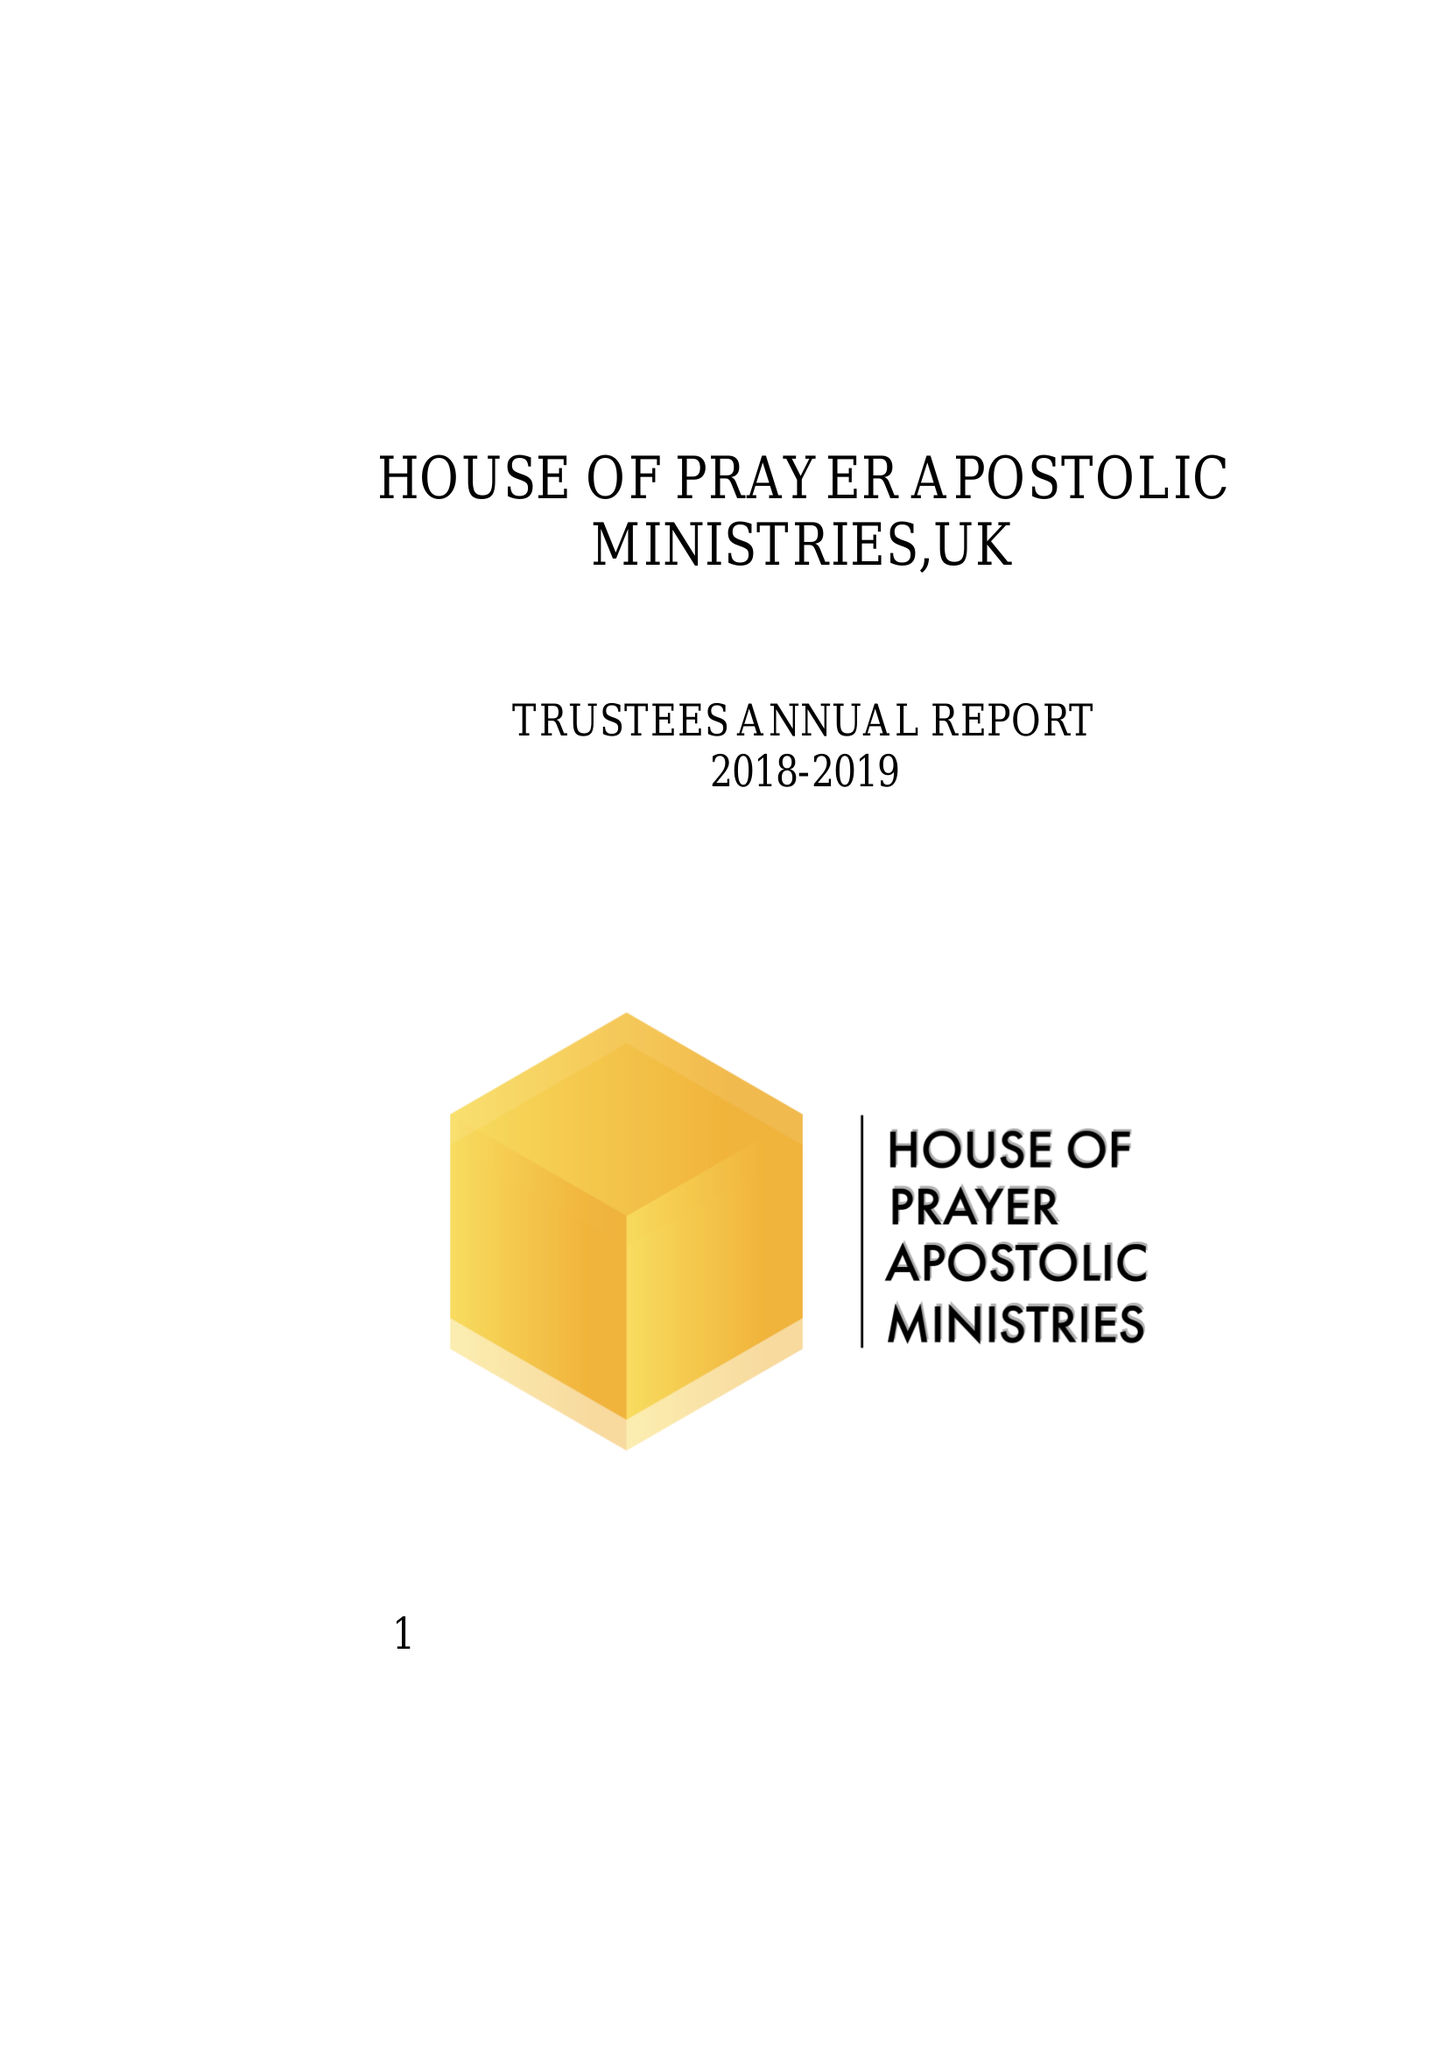What is the value for the income_annually_in_british_pounds?
Answer the question using a single word or phrase. 28207.00 